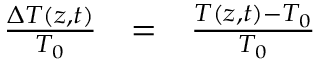<formula> <loc_0><loc_0><loc_500><loc_500>\begin{array} { c c l } { \frac { \Delta T ( z , t ) } { T _ { 0 } } } & { = } & { \frac { T ( z , t ) - T _ { 0 } } { T _ { 0 } } } \end{array}</formula> 